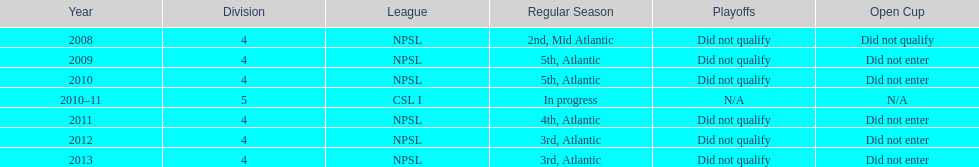Between 2010 and 2013, which year experienced greater success? 2013. 